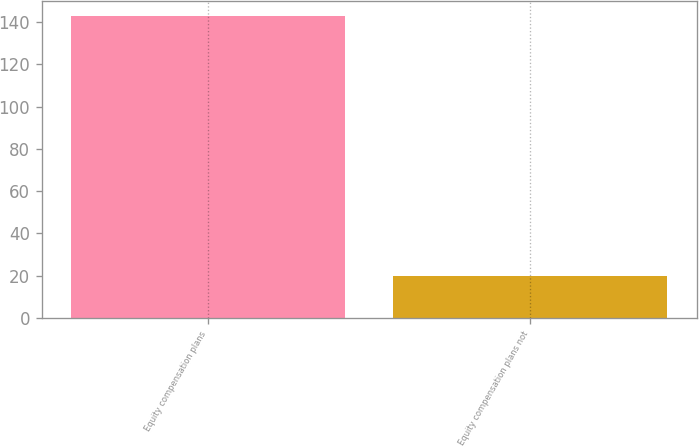<chart> <loc_0><loc_0><loc_500><loc_500><bar_chart><fcel>Equity compensation plans<fcel>Equity compensation plans not<nl><fcel>143<fcel>20<nl></chart> 